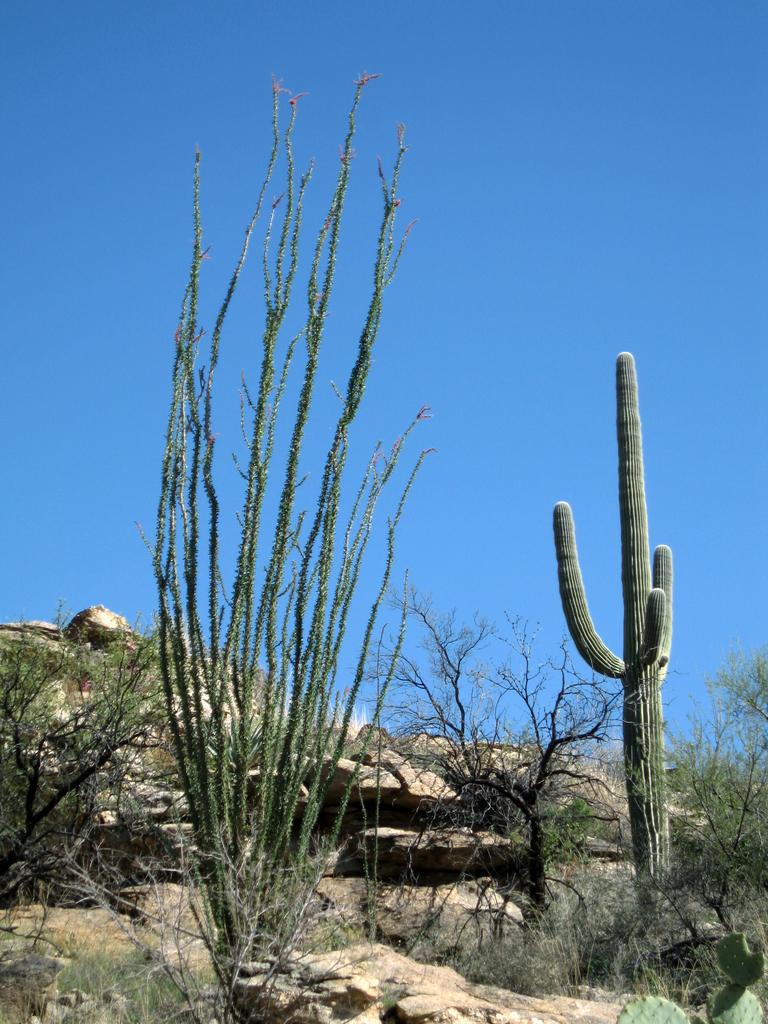What type of vegetation can be seen in the image? There are trees in the image. What other objects are present in the image? There are stones in the image. What can be seen in the background of the image? The sky is visible in the background of the image. How many beds can be seen in the image? There are no beds present in the image. What type of vest is being worn by the trees in the image? There are no vests present in the image, as the main subjects are trees and stones. 